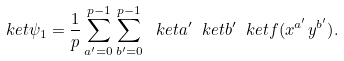Convert formula to latex. <formula><loc_0><loc_0><loc_500><loc_500>\ k e t { \psi _ { 1 } } = \frac { 1 } { p } \sum _ { a ^ { \prime } = 0 } ^ { p - 1 } \sum _ { b ^ { \prime } = 0 } ^ { p - 1 } \ k e t { a ^ { \prime } } \ k e t { b ^ { \prime } } \ k e t { f ( x ^ { a ^ { \prime } } y ^ { b ^ { \prime } } ) } .</formula> 